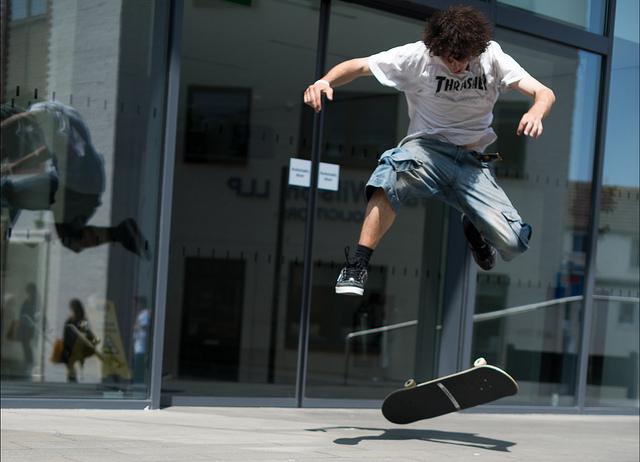Is the man facing towards the banister?
Give a very brief answer. No. Can this man get hurt doing what he's doing?
Give a very brief answer. Yes. What else is visible?
Short answer required. Building. What is on his shirt?
Be succinct. Thrasher. How many skateboarders are in mid-air in this picture?
Be succinct. 1. Is the person wearing a helmet?
Concise answer only. No. What color is his shoelace?
Concise answer only. Black. What is the man riding?
Give a very brief answer. Skateboard. 